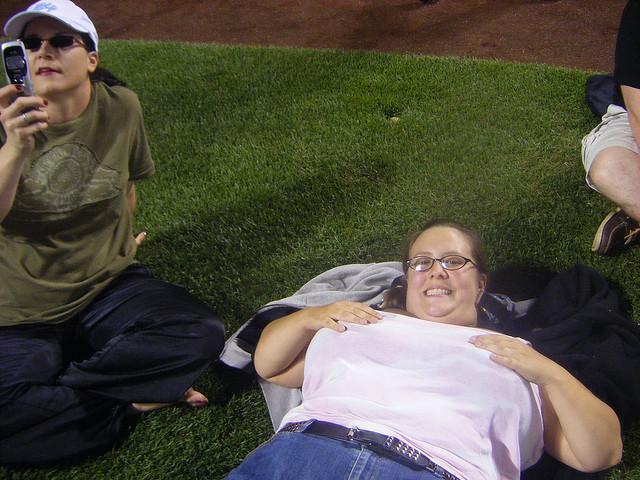How many people are in the picture?
Give a very brief answer. 3. How many people at the table are wearing tie dye?
Give a very brief answer. 0. 